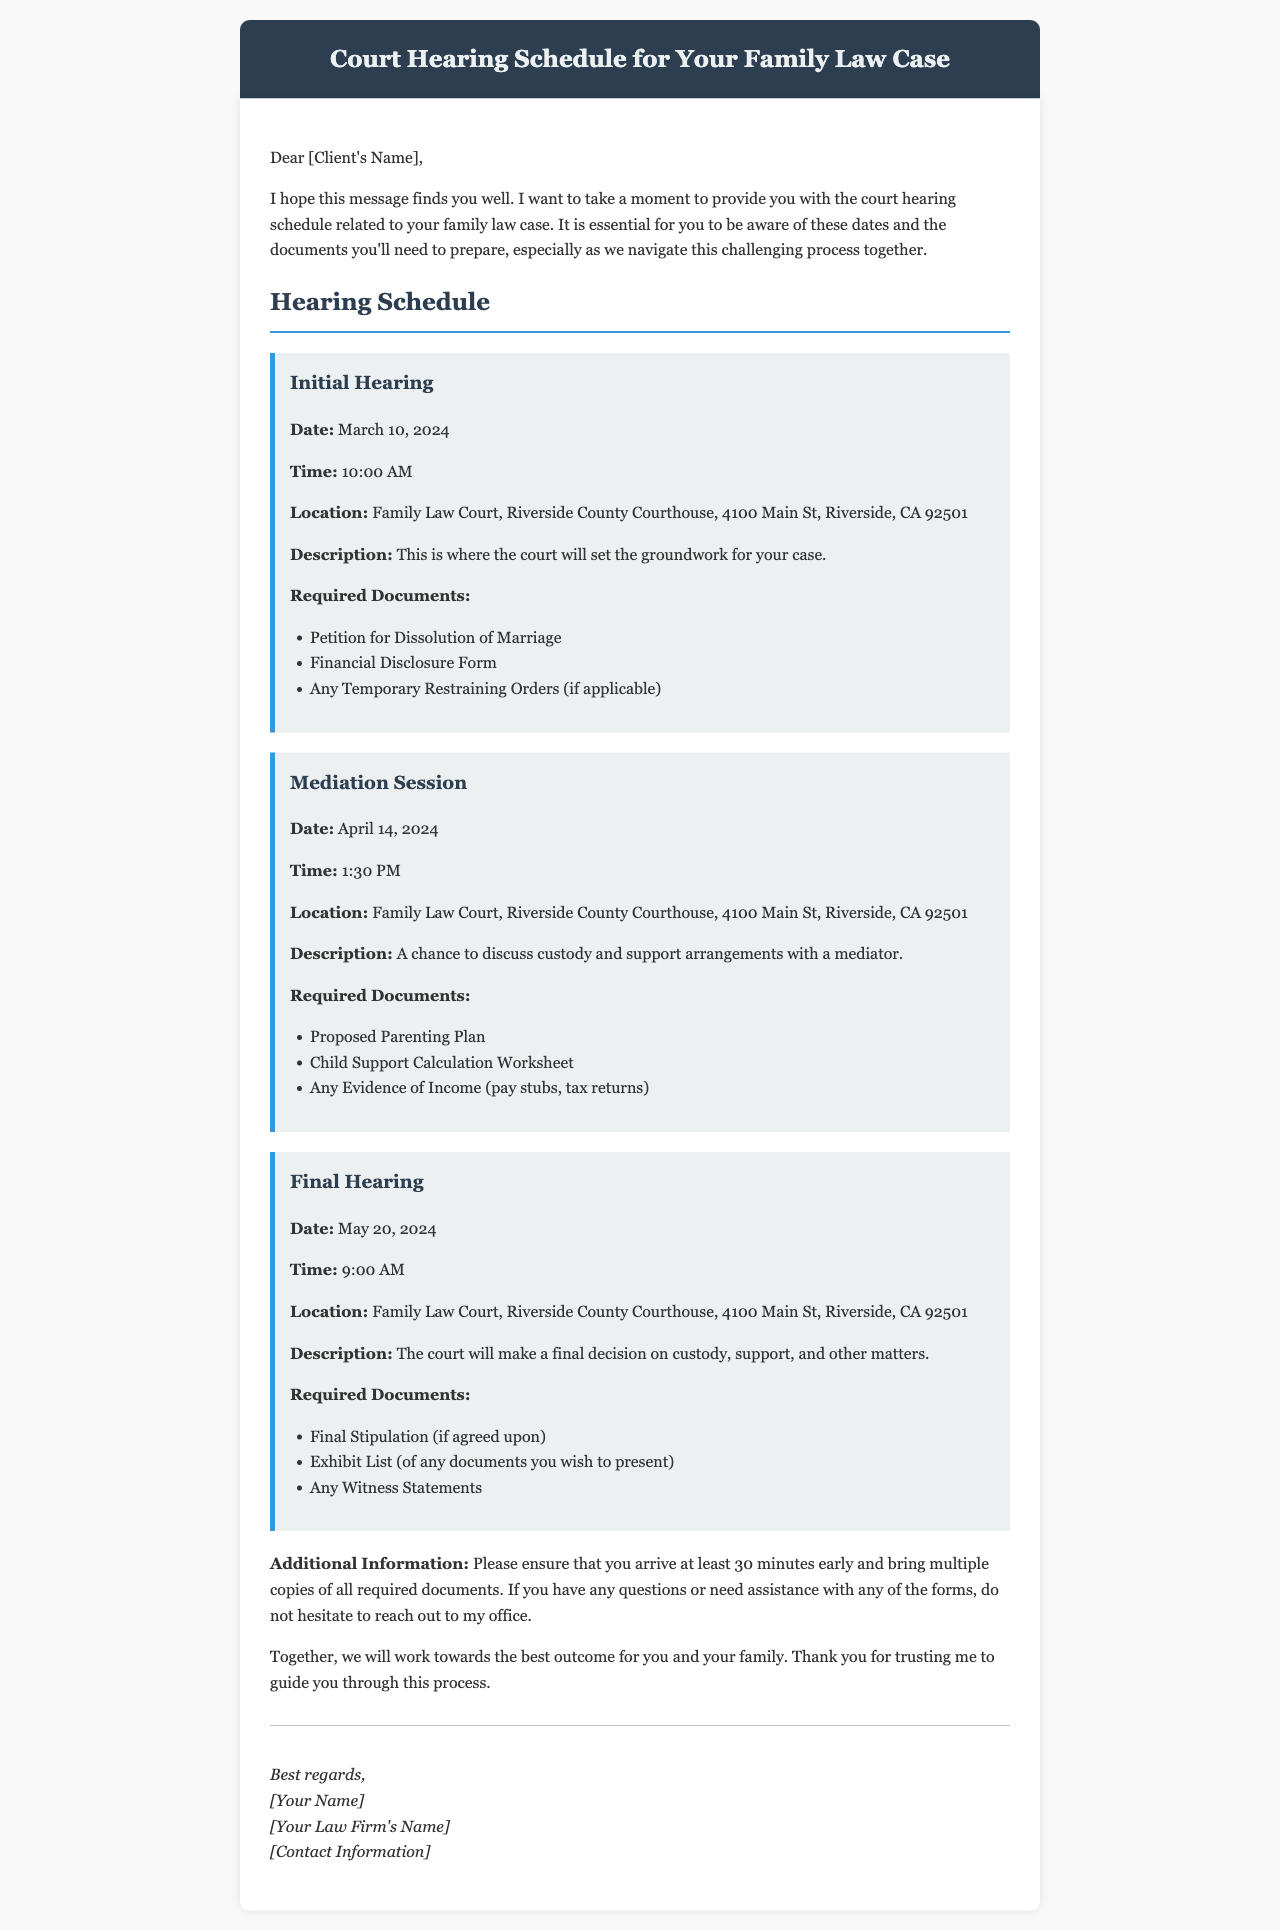What is the date of the Initial Hearing? The date of the Initial Hearing is clearly specified in the document as March 10, 2024.
Answer: March 10, 2024 What documents are required for the Mediation Session? The document lists specific required documents for each hearing; for the Mediation Session, these include the Proposed Parenting Plan, Child Support Calculation Worksheet, and Evidence of Income.
Answer: Proposed Parenting Plan, Child Support Calculation Worksheet, Evidence of Income What time does the Final Hearing start? The time for the Final Hearing is explicitly mentioned in the document as 9:00 AM.
Answer: 9:00 AM Where is the Family Law Court located? The document provides the location as the Riverside County Courthouse at 4100 Main St, Riverside, CA 92501.
Answer: Riverside County Courthouse, 4100 Main St, Riverside, CA 92501 How long should clients arrive before the hearings? The document advises arriving at least 30 minutes early to all hearings.
Answer: 30 minutes How many hearings are scheduled in total? The document outlines three specific hearings: Initial Hearing, Mediation Session, and Final Hearing; thus, the total is three.
Answer: Three What is the description of the Initial Hearing? The document includes brief descriptions for each hearing; for the Initial Hearing, it states that the court will set the groundwork for the case.
Answer: The court will set the groundwork for your case What should be done if the client has questions about forms? The document suggests that clients should not hesitate to reach out to the office with any questions about the forms.
Answer: Reach out to the office What type of document is this? The nature of this document is a mail that provides a schedule and information relevant to a family law case.
Answer: Mail 